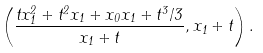Convert formula to latex. <formula><loc_0><loc_0><loc_500><loc_500>\left ( \frac { t x _ { 1 } ^ { 2 } + t ^ { 2 } x _ { 1 } + x _ { 0 } x _ { 1 } + t ^ { 3 } / 3 } { x _ { 1 } + t } , x _ { 1 } + t \right ) .</formula> 